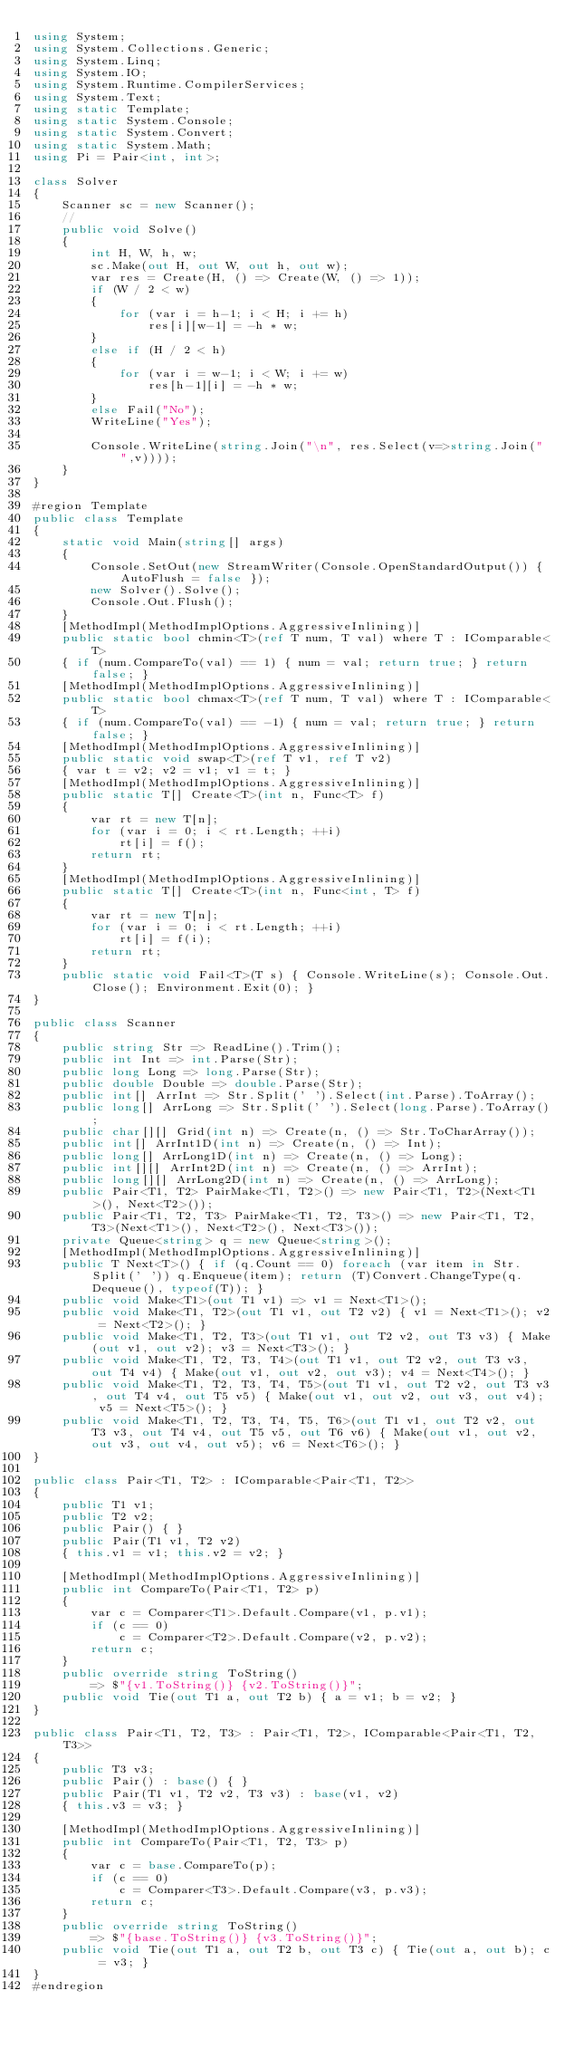<code> <loc_0><loc_0><loc_500><loc_500><_C#_>using System;
using System.Collections.Generic;
using System.Linq;
using System.IO;
using System.Runtime.CompilerServices;
using System.Text;
using static Template;
using static System.Console;
using static System.Convert;
using static System.Math;
using Pi = Pair<int, int>;

class Solver
{
    Scanner sc = new Scanner();
    //
    public void Solve()
    {
        int H, W, h, w;
        sc.Make(out H, out W, out h, out w);
        var res = Create(H, () => Create(W, () => 1));
        if (W / 2 < w)
        {
            for (var i = h-1; i < H; i += h)
                res[i][w-1] = -h * w;
        }
        else if (H / 2 < h)
        {
            for (var i = w-1; i < W; i += w)
                res[h-1][i] = -h * w;
        }
        else Fail("No");
        WriteLine("Yes");

        Console.WriteLine(string.Join("\n", res.Select(v=>string.Join(" ",v))));
    }
}

#region Template
public class Template
{
    static void Main(string[] args)
    {
        Console.SetOut(new StreamWriter(Console.OpenStandardOutput()) { AutoFlush = false });
        new Solver().Solve();
        Console.Out.Flush();
    }
    [MethodImpl(MethodImplOptions.AggressiveInlining)]
    public static bool chmin<T>(ref T num, T val) where T : IComparable<T>
    { if (num.CompareTo(val) == 1) { num = val; return true; } return false; }
    [MethodImpl(MethodImplOptions.AggressiveInlining)]
    public static bool chmax<T>(ref T num, T val) where T : IComparable<T>
    { if (num.CompareTo(val) == -1) { num = val; return true; } return false; }
    [MethodImpl(MethodImplOptions.AggressiveInlining)]
    public static void swap<T>(ref T v1, ref T v2)
    { var t = v2; v2 = v1; v1 = t; }
    [MethodImpl(MethodImplOptions.AggressiveInlining)]
    public static T[] Create<T>(int n, Func<T> f)
    {
        var rt = new T[n];
        for (var i = 0; i < rt.Length; ++i)
            rt[i] = f();
        return rt;
    }
    [MethodImpl(MethodImplOptions.AggressiveInlining)]
    public static T[] Create<T>(int n, Func<int, T> f)
    {
        var rt = new T[n];
        for (var i = 0; i < rt.Length; ++i)
            rt[i] = f(i);
        return rt;
    }
    public static void Fail<T>(T s) { Console.WriteLine(s); Console.Out.Close(); Environment.Exit(0); }
}

public class Scanner
{
    public string Str => ReadLine().Trim();
    public int Int => int.Parse(Str);
    public long Long => long.Parse(Str);
    public double Double => double.Parse(Str);
    public int[] ArrInt => Str.Split(' ').Select(int.Parse).ToArray();
    public long[] ArrLong => Str.Split(' ').Select(long.Parse).ToArray();
    public char[][] Grid(int n) => Create(n, () => Str.ToCharArray());
    public int[] ArrInt1D(int n) => Create(n, () => Int);
    public long[] ArrLong1D(int n) => Create(n, () => Long);
    public int[][] ArrInt2D(int n) => Create(n, () => ArrInt);
    public long[][] ArrLong2D(int n) => Create(n, () => ArrLong);
    public Pair<T1, T2> PairMake<T1, T2>() => new Pair<T1, T2>(Next<T1>(), Next<T2>());
    public Pair<T1, T2, T3> PairMake<T1, T2, T3>() => new Pair<T1, T2, T3>(Next<T1>(), Next<T2>(), Next<T3>());
    private Queue<string> q = new Queue<string>();
    [MethodImpl(MethodImplOptions.AggressiveInlining)]
    public T Next<T>() { if (q.Count == 0) foreach (var item in Str.Split(' ')) q.Enqueue(item); return (T)Convert.ChangeType(q.Dequeue(), typeof(T)); }
    public void Make<T1>(out T1 v1) => v1 = Next<T1>();
    public void Make<T1, T2>(out T1 v1, out T2 v2) { v1 = Next<T1>(); v2 = Next<T2>(); }
    public void Make<T1, T2, T3>(out T1 v1, out T2 v2, out T3 v3) { Make(out v1, out v2); v3 = Next<T3>(); }
    public void Make<T1, T2, T3, T4>(out T1 v1, out T2 v2, out T3 v3, out T4 v4) { Make(out v1, out v2, out v3); v4 = Next<T4>(); }
    public void Make<T1, T2, T3, T4, T5>(out T1 v1, out T2 v2, out T3 v3, out T4 v4, out T5 v5) { Make(out v1, out v2, out v3, out v4); v5 = Next<T5>(); }
    public void Make<T1, T2, T3, T4, T5, T6>(out T1 v1, out T2 v2, out T3 v3, out T4 v4, out T5 v5, out T6 v6) { Make(out v1, out v2, out v3, out v4, out v5); v6 = Next<T6>(); }
}

public class Pair<T1, T2> : IComparable<Pair<T1, T2>>
{
    public T1 v1;
    public T2 v2;
    public Pair() { }
    public Pair(T1 v1, T2 v2)
    { this.v1 = v1; this.v2 = v2; }

    [MethodImpl(MethodImplOptions.AggressiveInlining)]
    public int CompareTo(Pair<T1, T2> p)
    {
        var c = Comparer<T1>.Default.Compare(v1, p.v1);
        if (c == 0)
            c = Comparer<T2>.Default.Compare(v2, p.v2);
        return c;
    }
    public override string ToString()
        => $"{v1.ToString()} {v2.ToString()}";
    public void Tie(out T1 a, out T2 b) { a = v1; b = v2; }
}

public class Pair<T1, T2, T3> : Pair<T1, T2>, IComparable<Pair<T1, T2, T3>>
{
    public T3 v3;
    public Pair() : base() { }
    public Pair(T1 v1, T2 v2, T3 v3) : base(v1, v2)
    { this.v3 = v3; }

    [MethodImpl(MethodImplOptions.AggressiveInlining)]
    public int CompareTo(Pair<T1, T2, T3> p)
    {
        var c = base.CompareTo(p);
        if (c == 0)
            c = Comparer<T3>.Default.Compare(v3, p.v3);
        return c;
    }
    public override string ToString()
        => $"{base.ToString()} {v3.ToString()}";
    public void Tie(out T1 a, out T2 b, out T3 c) { Tie(out a, out b); c = v3; }
}
#endregion
</code> 